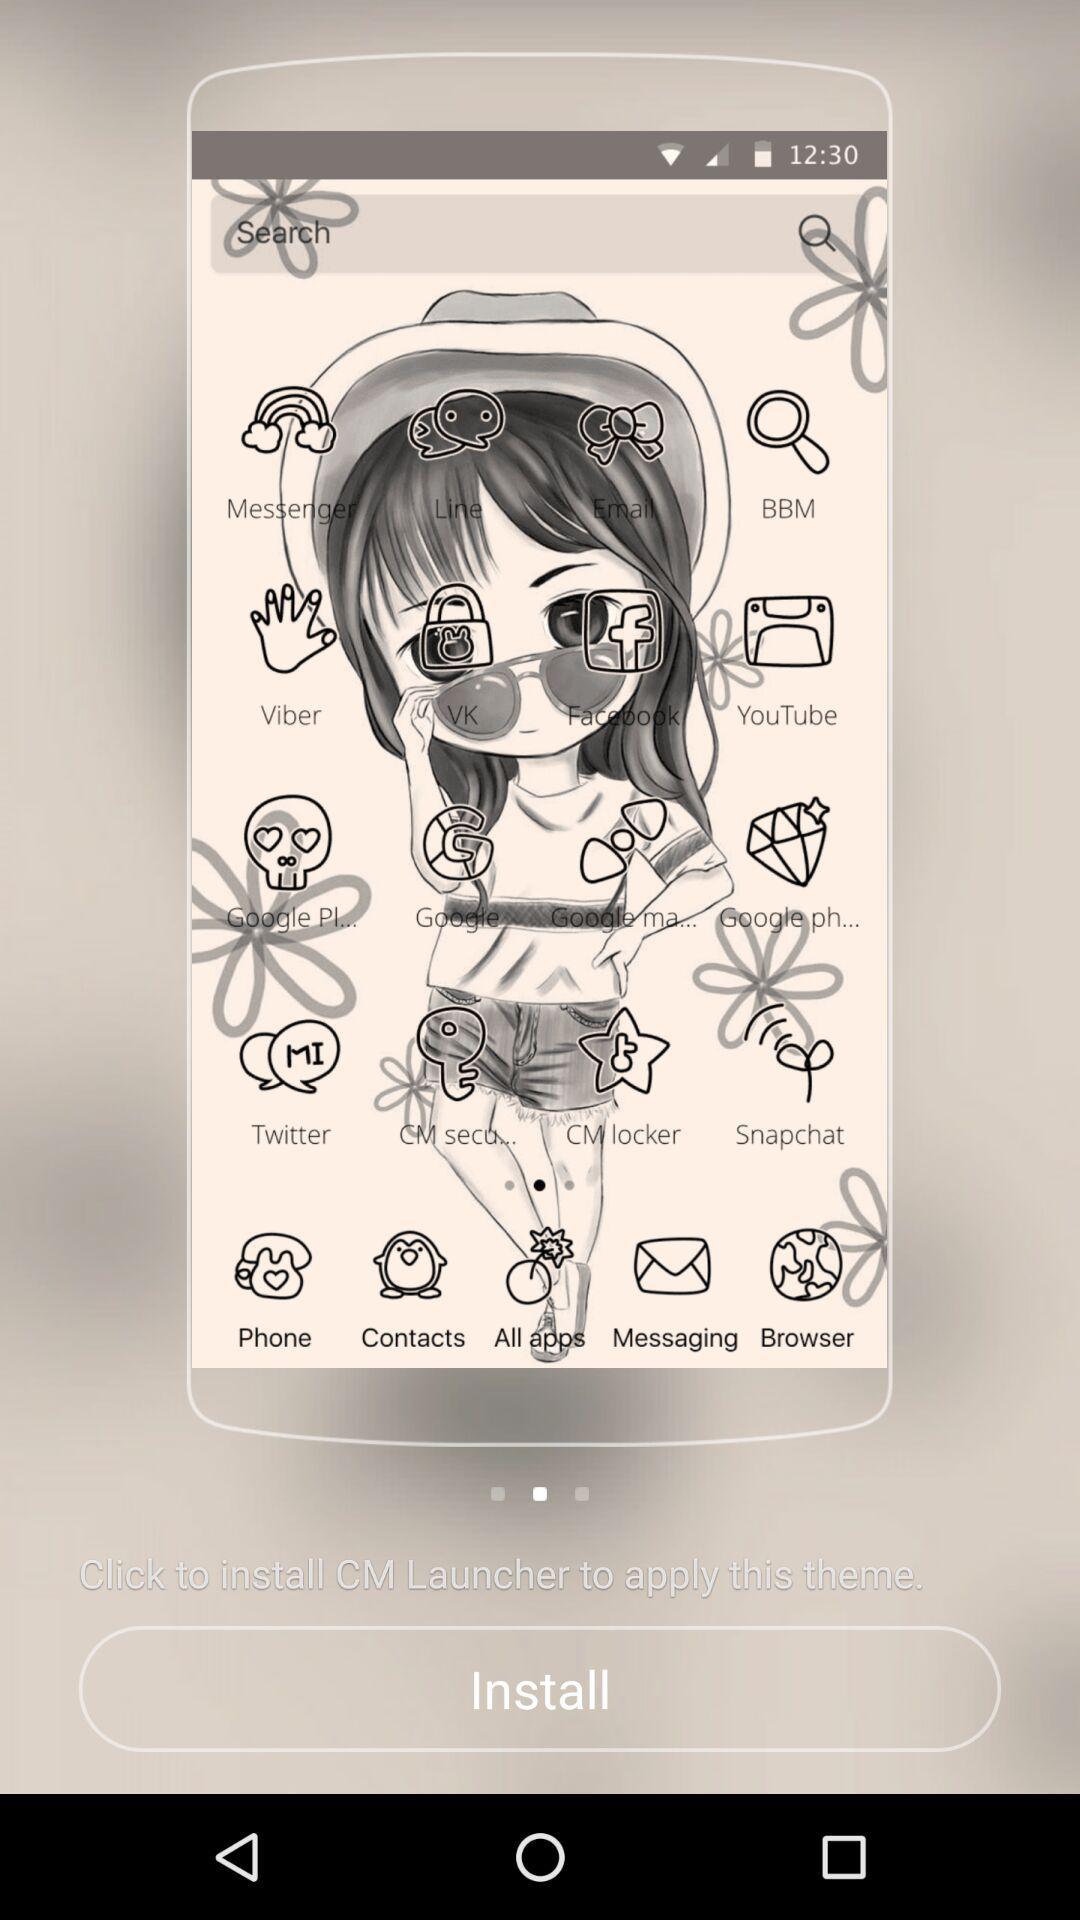What is the application name? The application name is "CM Launcher". 